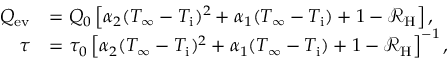Convert formula to latex. <formula><loc_0><loc_0><loc_500><loc_500>\begin{array} { r l } { Q _ { e v } } & { = Q _ { 0 } \left [ \alpha _ { 2 } ( T _ { \infty } - T _ { i } ) ^ { 2 } + \alpha _ { 1 } ( T _ { \infty } - T _ { i } ) + 1 - \mathcal { R } _ { H } \right ] , } \\ { \tau } & { = \tau _ { 0 } \left [ \alpha _ { 2 } ( T _ { \infty } - T _ { i } ) ^ { 2 } + \alpha _ { 1 } ( T _ { \infty } - T _ { i } ) + 1 - \mathcal { R } _ { H } \right ] ^ { - 1 } , } \end{array}</formula> 